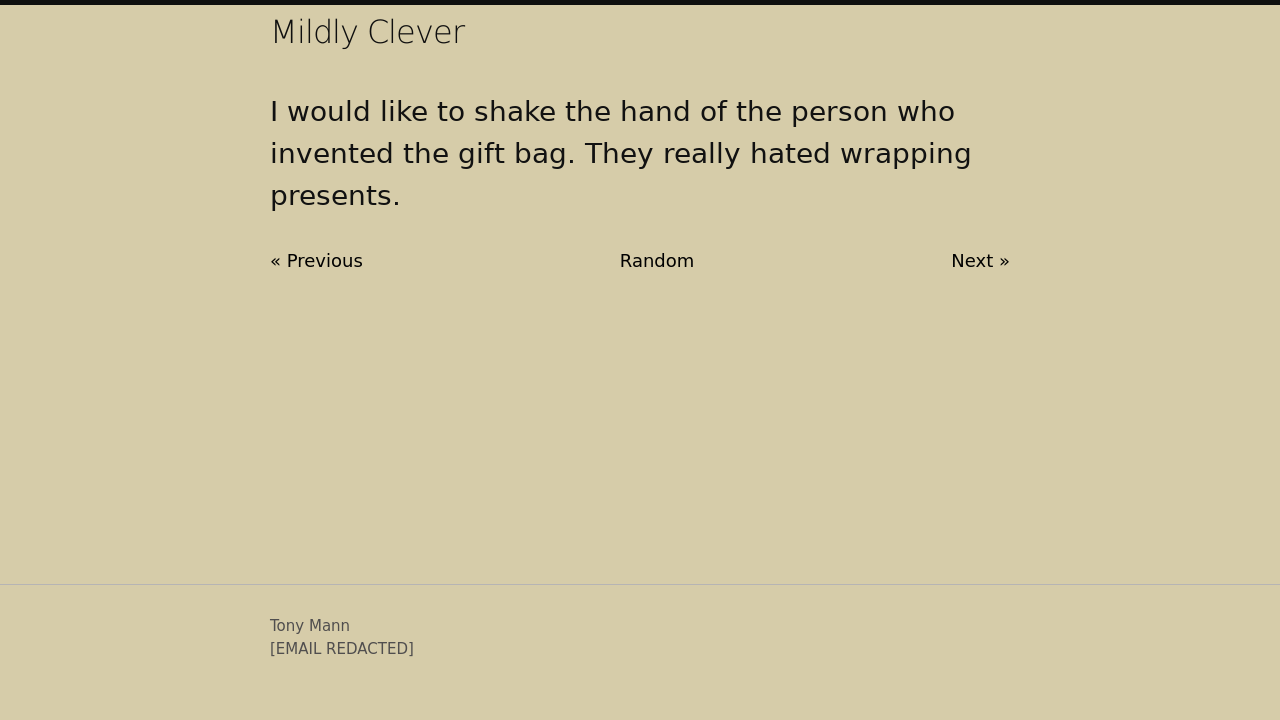How can I start building this website with HTML from the ground up? To start building a website with HTML from the ground up, you'll need a basic structure. Here's a simpler version than the provided which includes essential elements and explanations:

<!DOCTYPE html>
<html lang="en">
<head>
    <meta charset="UTF-8">
    <title>Your Website Title Here</title>
    <style>
        /* Add your CSS styling here */
        body {
            font-family: Arial, sans-serif;
        }
    </style>
</head>
<body>
    <header>
        <h1>Welcome to My Website</h1>
        <nav>
            <ul>
                <li><a href="#">Home</a></li>
                <li><a href="#">About</a></li>
                <li><a href="#">Contact</a></li>
            </ul>
        </nav>
    </header>
    <main>
        <section>
            <h2>Section Title</h2>
            <p>This is a paragraph in a section of your website. You can add more content here.</p>
        </section>
    </main>
    <footer>
        <p>Copyright © Your Name or Company Name</p>
    </footer>
</body>
</html>

This template provides you with the structural elements of a basic webpage, including the head and body sections, and placeholder tags for navigation and content. 